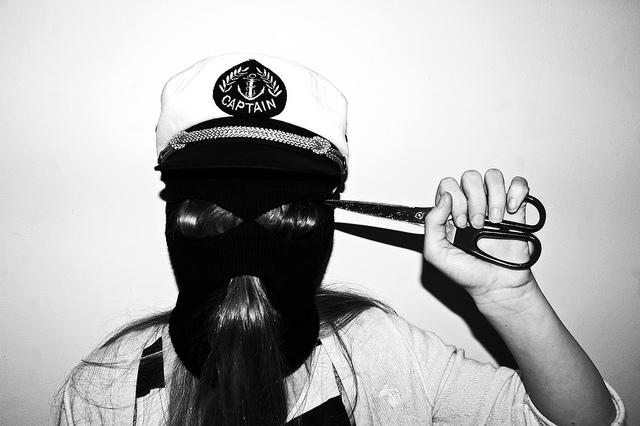What does the cap say?
Give a very brief answer. Captain. What is the man doing?
Write a very short answer. Cutting hair. What is weird about this scene?
Be succinct. Backwards. 